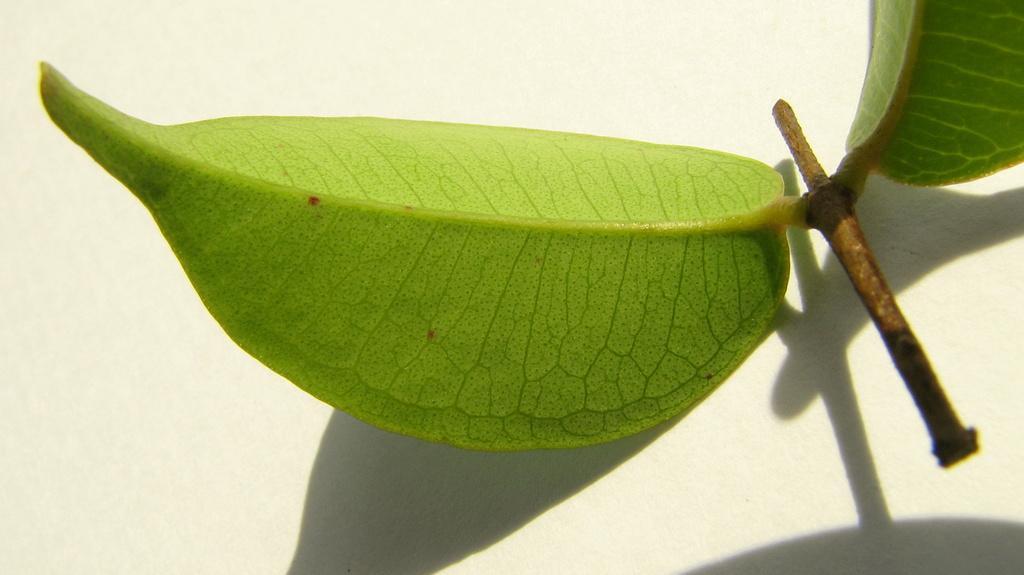Please provide a concise description of this image. In this image we can see one small stem with two green leaves on the surface. 